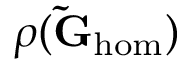Convert formula to latex. <formula><loc_0><loc_0><loc_500><loc_500>\rho ( \tilde { G } _ { h o m } )</formula> 